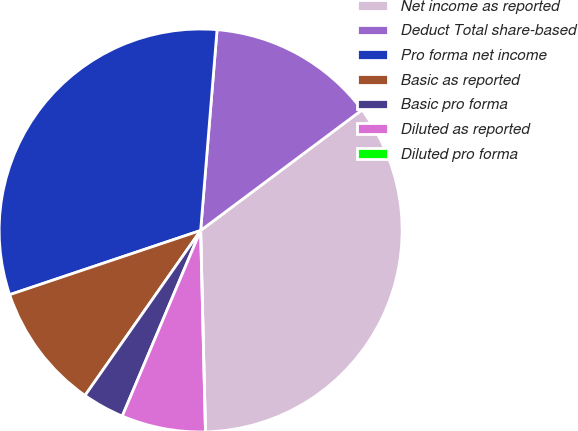Convert chart. <chart><loc_0><loc_0><loc_500><loc_500><pie_chart><fcel>Net income as reported<fcel>Deduct Total share-based<fcel>Pro forma net income<fcel>Basic as reported<fcel>Basic pro forma<fcel>Diluted as reported<fcel>Diluted pro forma<nl><fcel>34.83%<fcel>13.49%<fcel>31.46%<fcel>10.11%<fcel>3.37%<fcel>6.74%<fcel>0.0%<nl></chart> 